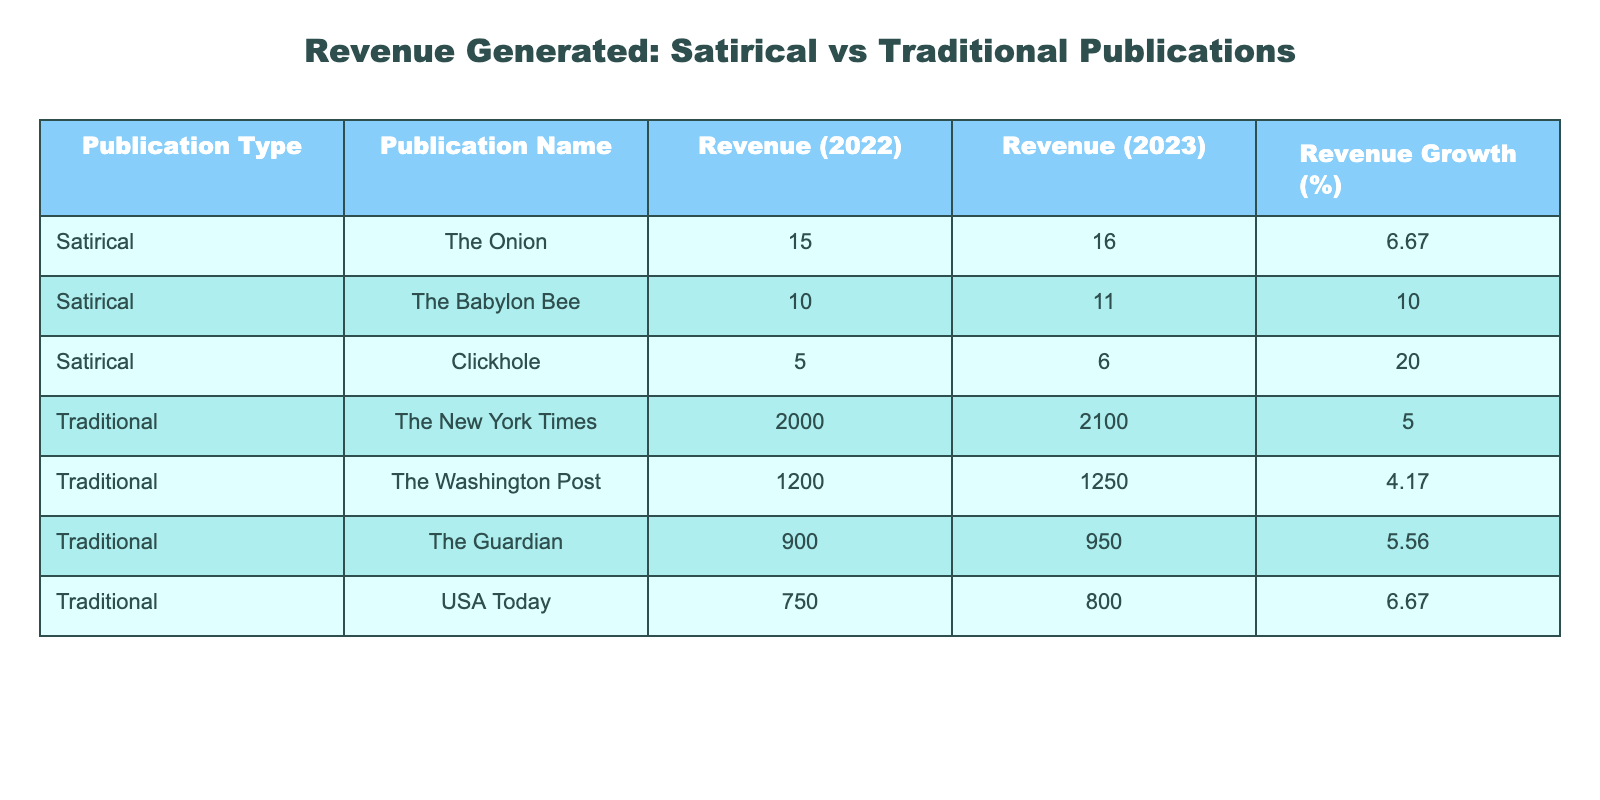What was the revenue for The Onion in 2023? The table directly lists The Onion's revenue for 2023, which is stated as 16.
Answer: 16 Which satirical publication had the highest revenue growth in 2023? By comparing the "Revenue Growth (%)" of the satirical publications, Clickhole has a growth of 20%, which is the highest among them.
Answer: Clickhole What is the total revenue generated by traditional journalism in 2023? Adding the revenues for all traditional publications in 2023: 2100 (The New York Times) + 1250 (The Washington Post) + 950 (The Guardian) + 800 (USA Today) = 4100.
Answer: 4100 Did The Washington Post generate more revenue in 2023 compared to The Guardian? Looking at the revenues, The Washington Post had a revenue of 1250 while The Guardian had 950 in 2023. Since 1250 is greater than 950, the answer is yes.
Answer: Yes What is the average revenue growth percentage for satirical publications? The growth percentages for satirical publications are 6.67%, 10%, 20%. Adding these gives 36.67, then dividing by the number of publications (3) yields an average of 36.67/3 = 12.22%.
Answer: 12.22% What was the combined revenue growth percentage for traditional journalism publications? Adding the growth percentages for the traditional publications: 5, 4.17, 5.56, and 6.67 gives a total of 21.40. Dividing by the number of traditional publications (4) provides the average growth percentage as 21.40/4 = 5.35%.
Answer: 5.35% Is the revenue of Clickhole in 2023 greater than the revenue of The Onion in the same year? The table shows Clickhole's revenue for 2023 as 6 and The Onion's as 16. Since 6 is less than 16, the answer is no.
Answer: No What is the total revenue for satirical publications in 2022? Adding the revenues for the satirical publications gives: 15 (The Onion) + 10 (The Babylon Bee) + 5 (Clickhole) = 30.
Answer: 30 